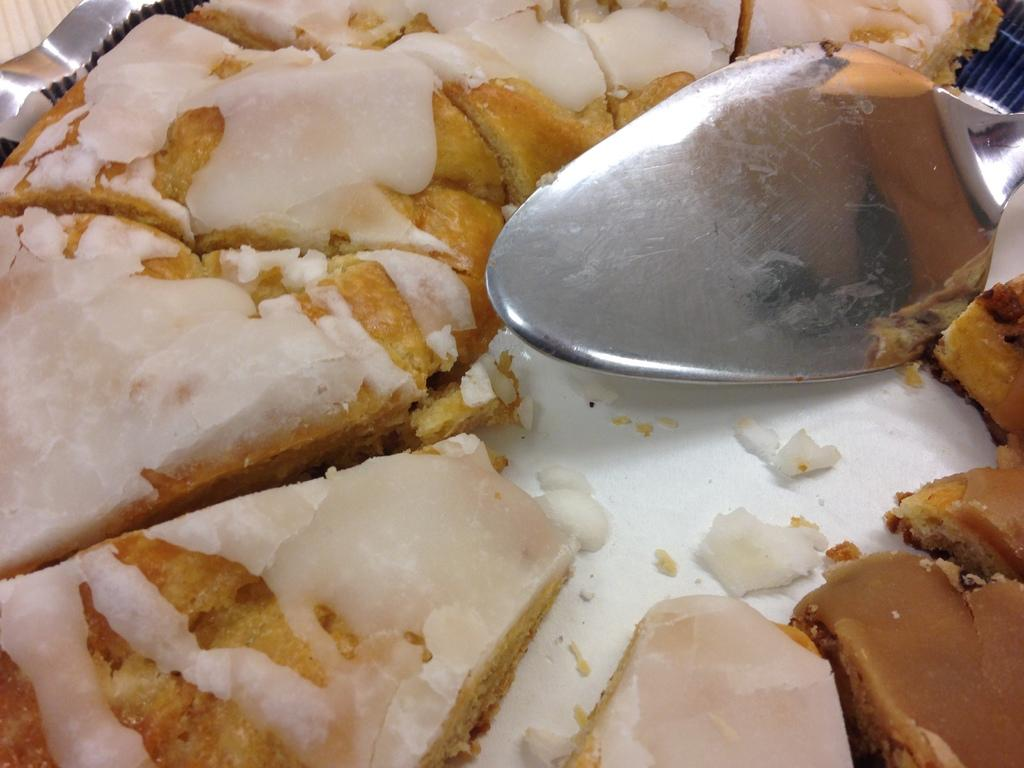What is the main subject of the image? There is a cake in the image. What object is present alongside the cake? There is a spoon in the image. What is the appearance of the cake? The cake has white color cream on it. What type of advice can be seen written on the cake in the image? There is no advice written on the cake in the image; it only has white color cream. What type of silk material is draped over the cake in the image? There is no silk material present in the image; it only features a cake with white color cream and a spoon. 